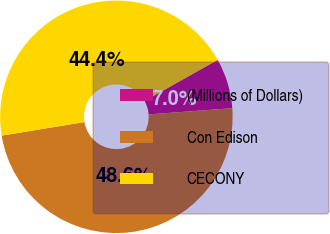Convert chart to OTSL. <chart><loc_0><loc_0><loc_500><loc_500><pie_chart><fcel>(Millions of Dollars)<fcel>Con Edison<fcel>CECONY<nl><fcel>6.97%<fcel>48.59%<fcel>44.44%<nl></chart> 